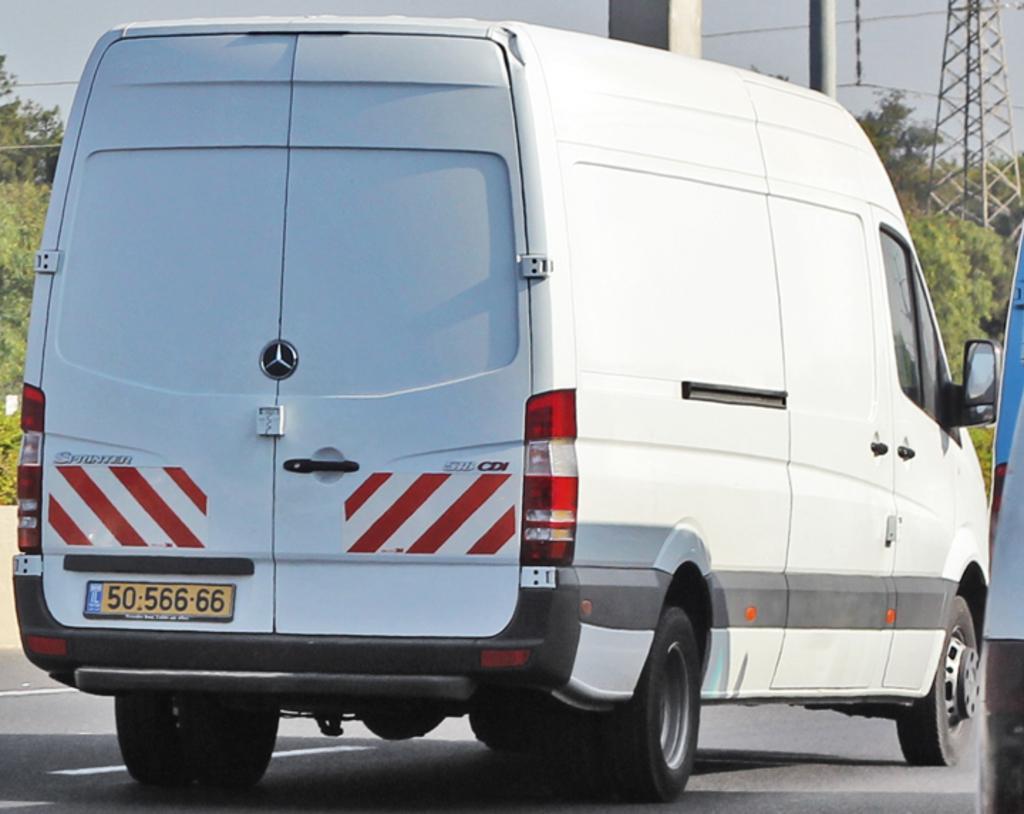Could you give a brief overview of what you see in this image? In this image in the center there are vehicles moving on the road. In the background there are poles, trees and the sky is cloudy. 